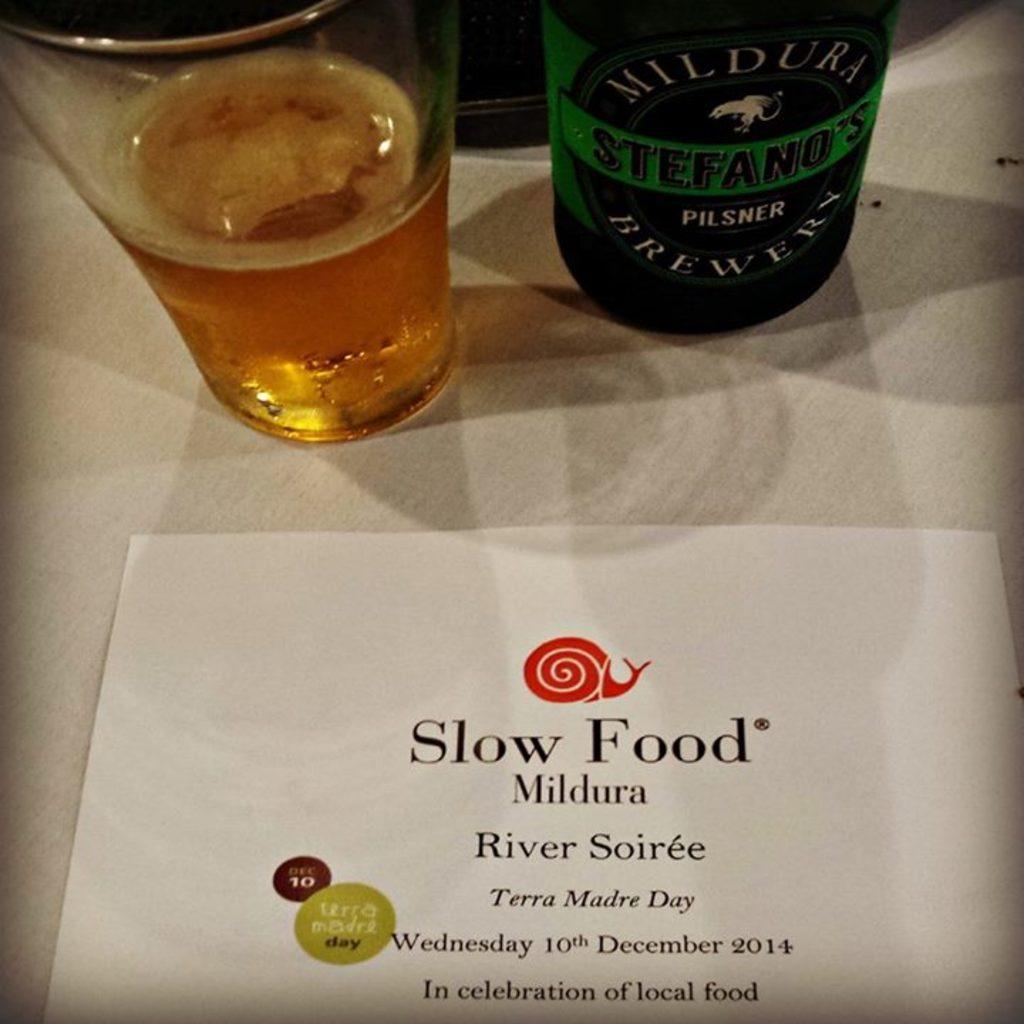When did the event take place?
Offer a very short reply. Wednesday 10th december 2014. 